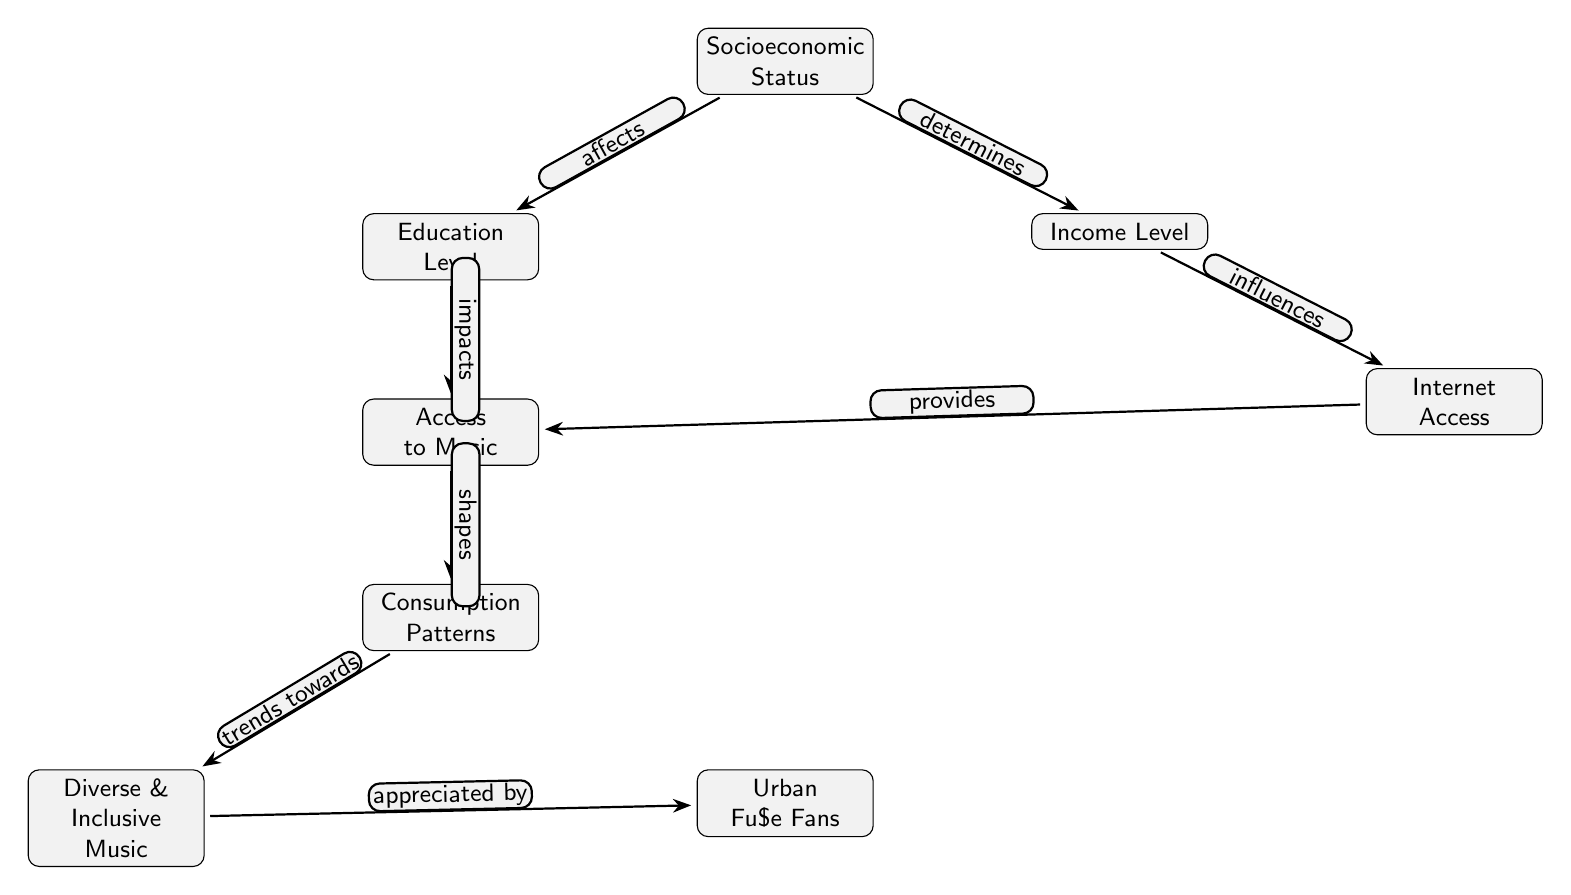What is the main factor mentioned in the diagram that affects education level? The diagram indicates that the main factor affecting education level is socioeconomic status, as indicated by the arrow pointing from "Socioeconomic Status" to "Education Level."
Answer: Socioeconomic Status How many nodes are present in the diagram? The diagram displays a total of six nodes: Socioeconomic Status, Education Level, Income Level, Internet Access, Access to Music, Consumption Patterns, Diverse & Inclusive Music, and Urban Fu$e Fans, making it eight nodes in total.
Answer: Eight Which node is influenced by income level according to the diagram? The diagram shows that "Income Level" influences "Internet Access," as indicated by the directed edge connecting those two nodes.
Answer: Internet Access What does access to music shape according to the flow of the diagram? The diagram indicates that "Access to Music" shapes "Consumption Patterns," as indicated by the directed edge going from "Access to Music" to "Consumption Patterns."
Answer: Consumption Patterns What type of music trends towards Urban Fu$e fans? The diagram clearly states that "Diverse & Inclusive Music" trends towards "Urban Fu$e Fans," as indicated by the directed edge pointing from "Diverse & Inclusive Music" to "Urban Fu$e Fans."
Answer: Diverse & Inclusive Music What presents a barrier to access to music as inferred from the diagram? Given that "Internet Access" influences "Access to Music," if Internet Access is limited, it presents a barrier to access to music. This is inferred from the flow but is not explicitly stated; however, logically, limited internet access hinders music access.
Answer: Internet Access How does socioeconomic status determine income level? The flow in the diagram indicates that "Socioeconomic Status" determines "Income Level," which suggests that higher or lower socioeconomic status leads to corresponding levels of income, establishing this causal relationship.
Answer: Income Level Which factors combine to shape consumption patterns according to the diagram? The diagram suggests that both "Access to Music" and "Consumption Patterns" directly influence each other, meaning these two nodes are critical in shaping overall consumption behavior. To answer the question, access and consumption are the factors.
Answer: Access to Music and Consumption Patterns 